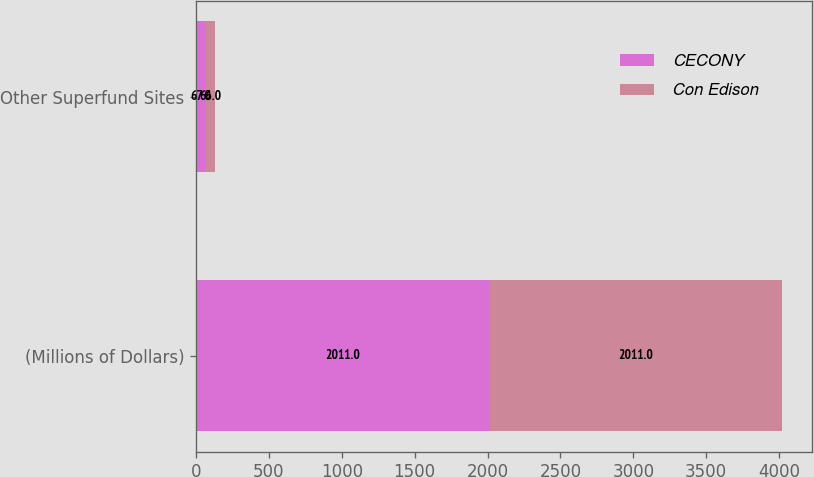Convert chart to OTSL. <chart><loc_0><loc_0><loc_500><loc_500><stacked_bar_chart><ecel><fcel>(Millions of Dollars)<fcel>Other Superfund Sites<nl><fcel>CECONY<fcel>2011<fcel>67<nl><fcel>Con Edison<fcel>2011<fcel>66<nl></chart> 